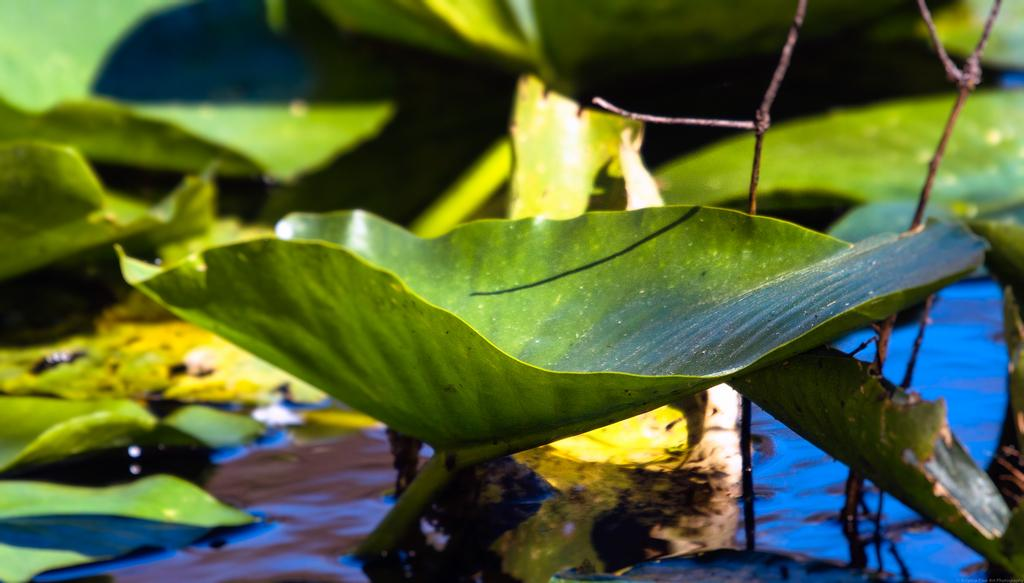What is the primary subject of the image? The primary subject of the image is many plants. Can you describe the environment in the image? There is water visible in the image. What color is the crayon used to draw the plants in the image? There is no crayon present in the image, as the plants are real and not drawn. How does the sister contribute to the growth of the plants in the image? There is no mention of a sister in the image, so it is not possible to determine her contribution to the growth of the plants. 